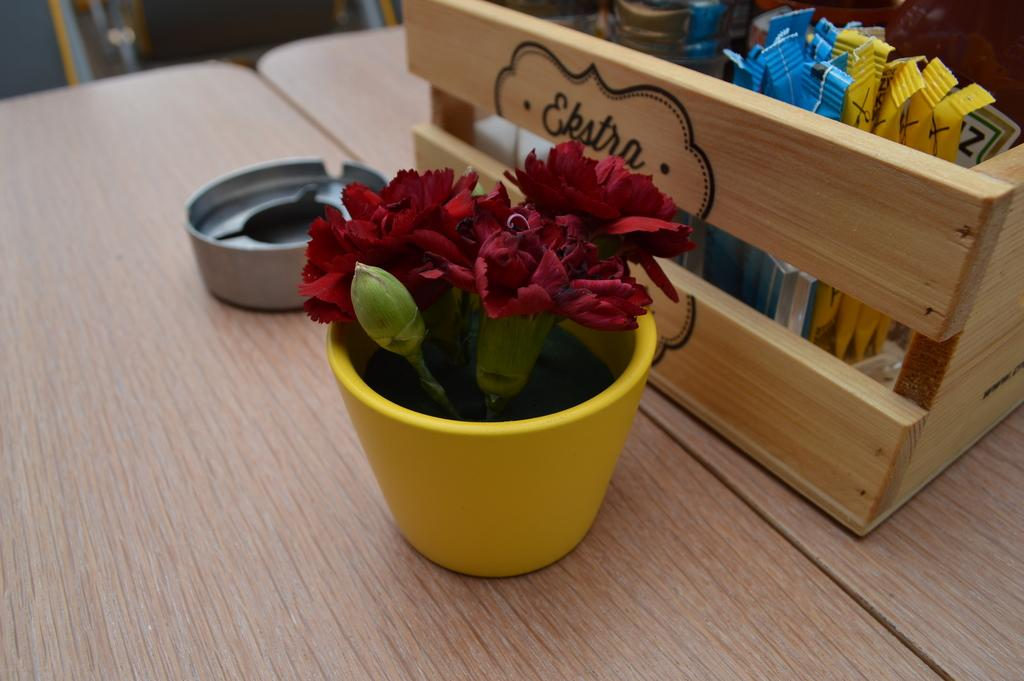What type of surface is visible in the image? There is a wooden surface in the image. What is placed on the wooden surface? There is a yellow pot with flowers and a wooden basket with items on the wooden surface. What other object can be seen on the wooden surface? There is an ashtray on the wooden surface. How many forks are visible in the image? There are no forks present in the image. Is there a pig resting on the wooden surface in the image? There is no pig present in the image. 